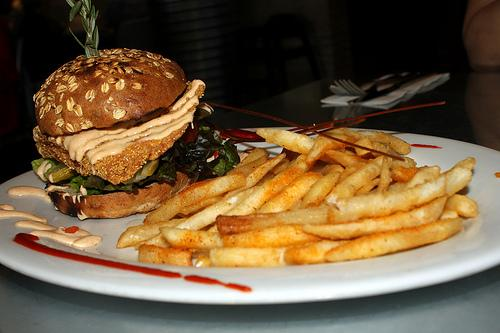What kind of vegetables are on the hamburger? Lettuce and pickles are on the hamburger. Provide a brief description of the scene in the image. A large hamburger and french fries on a white plate at a restaurant, with ketchup, thousand island sauce, and silverware in the background. Identify the type of meat used in the hamburger and how it is prepared. The meat in the hamburger is breaded. What are the fork and knife resting upon? The fork and knife are resting on a napkin. Mention two types of sauce present in the image and where they are located. Ketchup and thousand island sauce are on the plate, close to french fries and the burger. What type of seeds are on the bun of the hamburger? Oat seeds are on the bun of the hamburger. In a short sentence, explain the state of the french fries. The french fries are fresh, golden, and seasoned. Describe the plate and its contents in the image. The plate is white and it contains a large burger, french fries, ketchup, thousand island sauce, and decorative accents. Count the number of items that can be associated with french fries in the image. There are 11 items associated with french fries in the image. Where are the lettuce and pickles situated? Lettuce and pickles are on the sandwich. What kind of dressing is on the sandwich besides ketchup? Thousand island sauce What does the napkin have on it? The napkin has a spoon, fork, and knife. Describe the location of the fork and knife. The fork and knife are in the distance, on a napkin. What element adds to the burger's visual appeal? Decorative accents on the plate What is the main food item on the plate? Hamburger Describe the design created by the sauces. There is a long line of ketchup and drizzled mayonnaise with thousand island on the plate. Select the right statement about the bun: (a) The bun has sesame seeds. (b) The bun has oat seeds. (c) The bun is plain. The bun has oat seeds. Are there chocolate chips on top of the oatmeal bun? No, it's not mentioned in the image. Briefly describe what the silverware is doing. The silverware is laying on the napkin, ready for use. What activity can be inferred from the presence of the knife and fork? People will use the knife and fork to eat the food. Mention one additional item on the plate other than the burger and fries. There is sauce design on the plate. What is the color of the plate? White State the arrangement of the plate and table. The white plate is on a brown table with a reflection on the table. Provide a brief description of the entire scene. The scene showcases a large burger with various toppings, golden french fries, sauces, and silverware on a napkin, all on a white plate on a brown table. What type of meat is used in the hamburger? Breaded meat What can be inferred about the table's surface? The table's surface is reflective, as there is a reflection on it. Give a detailed description of the burger and its toppings. The burger has a bun with oat seeds, breaded meat, greens such as lettuce and pickles, and some vegetable sticking out. How can you characterize the french fries' appearance? The french fries are golden, fresh, and seasoned. What kind of sauce is on the plate? Ketchup and thousand island sauce 